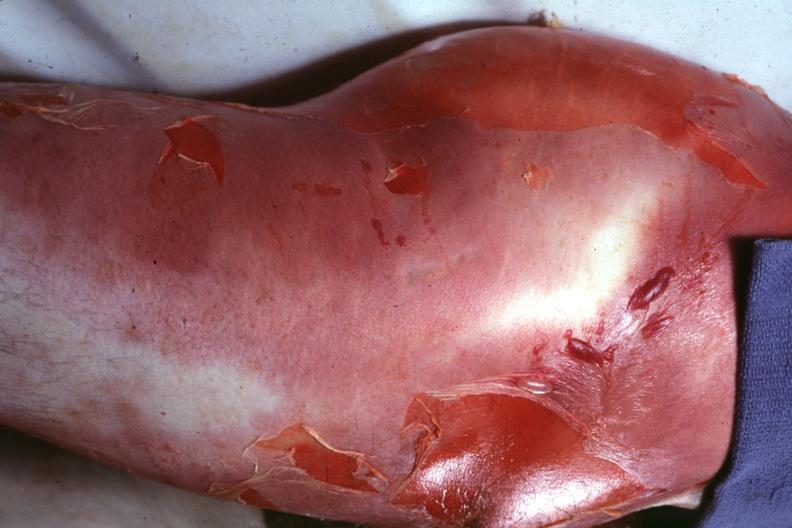does immunostain for growth hormone show buttock and thigh with severe cellulitis and desquamation caused by a clostridium?
Answer the question using a single word or phrase. No 